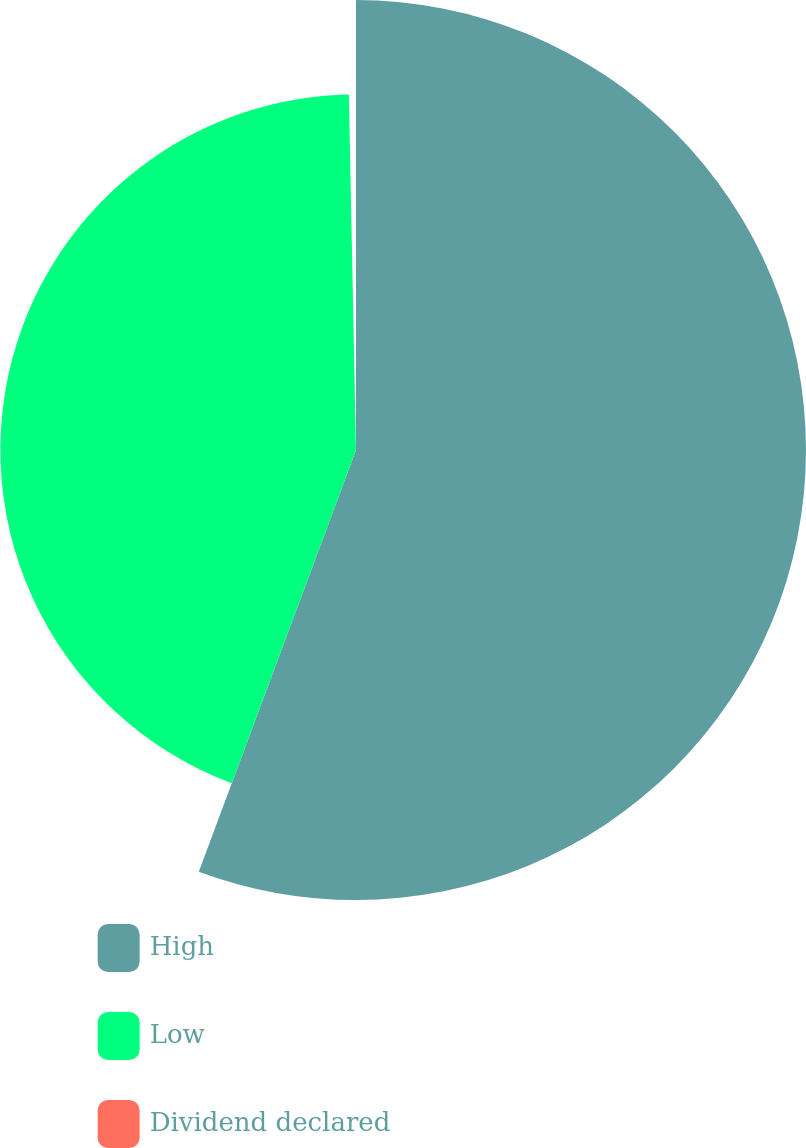<chart> <loc_0><loc_0><loc_500><loc_500><pie_chart><fcel>High<fcel>Low<fcel>Dividend declared<nl><fcel>55.68%<fcel>44.0%<fcel>0.32%<nl></chart> 